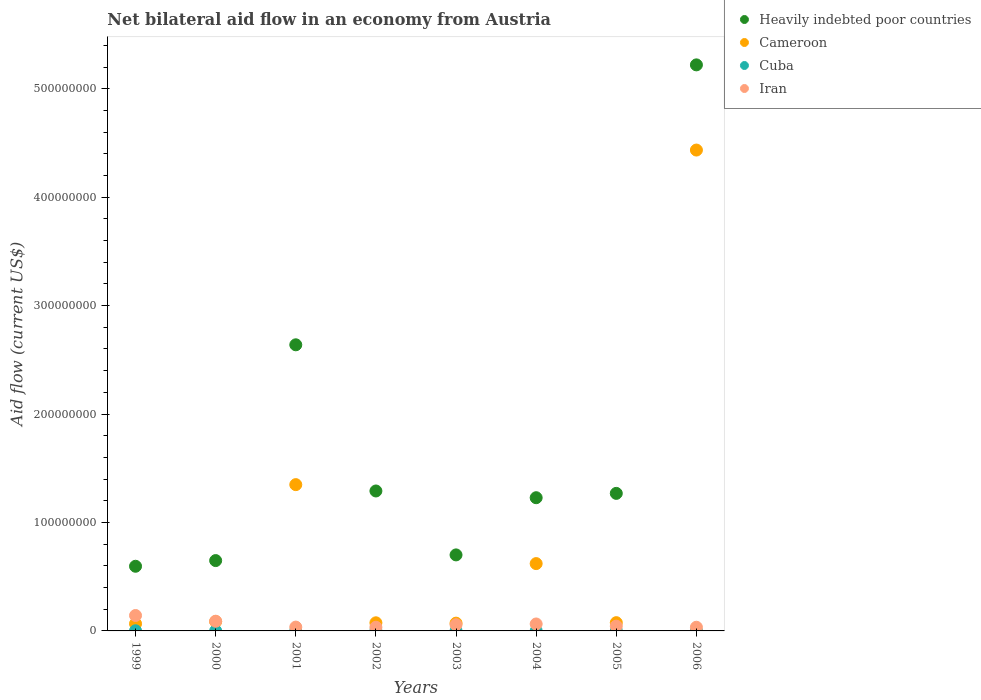Is the number of dotlines equal to the number of legend labels?
Your answer should be compact. Yes. What is the net bilateral aid flow in Cameroon in 2002?
Ensure brevity in your answer.  7.49e+06. Across all years, what is the minimum net bilateral aid flow in Heavily indebted poor countries?
Your answer should be compact. 5.96e+07. In which year was the net bilateral aid flow in Cuba maximum?
Provide a short and direct response. 2002. What is the total net bilateral aid flow in Cuba in the graph?
Make the answer very short. 9.40e+05. What is the difference between the net bilateral aid flow in Heavily indebted poor countries in 2005 and the net bilateral aid flow in Iran in 2001?
Give a very brief answer. 1.23e+08. What is the average net bilateral aid flow in Heavily indebted poor countries per year?
Ensure brevity in your answer.  1.70e+08. In the year 2005, what is the difference between the net bilateral aid flow in Cameroon and net bilateral aid flow in Iran?
Offer a terse response. 3.21e+06. What is the ratio of the net bilateral aid flow in Cameroon in 1999 to that in 2004?
Ensure brevity in your answer.  0.11. Is the net bilateral aid flow in Iran in 2001 less than that in 2006?
Give a very brief answer. No. Is the difference between the net bilateral aid flow in Cameroon in 1999 and 2006 greater than the difference between the net bilateral aid flow in Iran in 1999 and 2006?
Make the answer very short. No. What is the difference between the highest and the second highest net bilateral aid flow in Iran?
Your answer should be very brief. 5.27e+06. What is the difference between the highest and the lowest net bilateral aid flow in Heavily indebted poor countries?
Your response must be concise. 4.62e+08. Is the sum of the net bilateral aid flow in Cameroon in 1999 and 2006 greater than the maximum net bilateral aid flow in Iran across all years?
Keep it short and to the point. Yes. Does the net bilateral aid flow in Cuba monotonically increase over the years?
Ensure brevity in your answer.  No. Is the net bilateral aid flow in Heavily indebted poor countries strictly greater than the net bilateral aid flow in Cuba over the years?
Make the answer very short. Yes. Is the net bilateral aid flow in Iran strictly less than the net bilateral aid flow in Heavily indebted poor countries over the years?
Give a very brief answer. Yes. Are the values on the major ticks of Y-axis written in scientific E-notation?
Your answer should be very brief. No. Does the graph contain any zero values?
Offer a very short reply. No. Where does the legend appear in the graph?
Keep it short and to the point. Top right. What is the title of the graph?
Your response must be concise. Net bilateral aid flow in an economy from Austria. Does "Mongolia" appear as one of the legend labels in the graph?
Keep it short and to the point. No. What is the label or title of the Y-axis?
Your answer should be compact. Aid flow (current US$). What is the Aid flow (current US$) of Heavily indebted poor countries in 1999?
Ensure brevity in your answer.  5.96e+07. What is the Aid flow (current US$) in Cameroon in 1999?
Your answer should be very brief. 6.63e+06. What is the Aid flow (current US$) in Cuba in 1999?
Your answer should be very brief. 1.40e+05. What is the Aid flow (current US$) of Iran in 1999?
Your answer should be very brief. 1.42e+07. What is the Aid flow (current US$) in Heavily indebted poor countries in 2000?
Your answer should be compact. 6.49e+07. What is the Aid flow (current US$) of Cameroon in 2000?
Your response must be concise. 8.60e+06. What is the Aid flow (current US$) in Cuba in 2000?
Keep it short and to the point. 1.10e+05. What is the Aid flow (current US$) of Iran in 2000?
Your answer should be very brief. 8.95e+06. What is the Aid flow (current US$) in Heavily indebted poor countries in 2001?
Keep it short and to the point. 2.64e+08. What is the Aid flow (current US$) of Cameroon in 2001?
Provide a succinct answer. 1.35e+08. What is the Aid flow (current US$) in Cuba in 2001?
Offer a terse response. 9.00e+04. What is the Aid flow (current US$) of Iran in 2001?
Give a very brief answer. 3.53e+06. What is the Aid flow (current US$) in Heavily indebted poor countries in 2002?
Offer a very short reply. 1.29e+08. What is the Aid flow (current US$) in Cameroon in 2002?
Make the answer very short. 7.49e+06. What is the Aid flow (current US$) in Iran in 2002?
Make the answer very short. 3.38e+06. What is the Aid flow (current US$) of Heavily indebted poor countries in 2003?
Your answer should be compact. 7.01e+07. What is the Aid flow (current US$) in Cameroon in 2003?
Offer a very short reply. 7.17e+06. What is the Aid flow (current US$) of Iran in 2003?
Ensure brevity in your answer.  5.73e+06. What is the Aid flow (current US$) of Heavily indebted poor countries in 2004?
Offer a very short reply. 1.23e+08. What is the Aid flow (current US$) of Cameroon in 2004?
Keep it short and to the point. 6.21e+07. What is the Aid flow (current US$) of Cuba in 2004?
Offer a terse response. 1.00e+05. What is the Aid flow (current US$) in Iran in 2004?
Offer a very short reply. 6.40e+06. What is the Aid flow (current US$) in Heavily indebted poor countries in 2005?
Give a very brief answer. 1.27e+08. What is the Aid flow (current US$) in Cameroon in 2005?
Your answer should be compact. 7.61e+06. What is the Aid flow (current US$) in Iran in 2005?
Give a very brief answer. 4.40e+06. What is the Aid flow (current US$) in Heavily indebted poor countries in 2006?
Keep it short and to the point. 5.22e+08. What is the Aid flow (current US$) of Cameroon in 2006?
Offer a very short reply. 4.43e+08. What is the Aid flow (current US$) in Iran in 2006?
Offer a very short reply. 3.40e+06. Across all years, what is the maximum Aid flow (current US$) of Heavily indebted poor countries?
Your response must be concise. 5.22e+08. Across all years, what is the maximum Aid flow (current US$) of Cameroon?
Provide a short and direct response. 4.43e+08. Across all years, what is the maximum Aid flow (current US$) of Iran?
Your answer should be compact. 1.42e+07. Across all years, what is the minimum Aid flow (current US$) of Heavily indebted poor countries?
Give a very brief answer. 5.96e+07. Across all years, what is the minimum Aid flow (current US$) of Cameroon?
Keep it short and to the point. 6.63e+06. Across all years, what is the minimum Aid flow (current US$) in Iran?
Make the answer very short. 3.38e+06. What is the total Aid flow (current US$) in Heavily indebted poor countries in the graph?
Your answer should be very brief. 1.36e+09. What is the total Aid flow (current US$) in Cameroon in the graph?
Your answer should be very brief. 6.78e+08. What is the total Aid flow (current US$) in Cuba in the graph?
Your response must be concise. 9.40e+05. What is the total Aid flow (current US$) of Iran in the graph?
Provide a succinct answer. 5.00e+07. What is the difference between the Aid flow (current US$) in Heavily indebted poor countries in 1999 and that in 2000?
Offer a very short reply. -5.24e+06. What is the difference between the Aid flow (current US$) in Cameroon in 1999 and that in 2000?
Your answer should be very brief. -1.97e+06. What is the difference between the Aid flow (current US$) of Cuba in 1999 and that in 2000?
Make the answer very short. 3.00e+04. What is the difference between the Aid flow (current US$) in Iran in 1999 and that in 2000?
Offer a very short reply. 5.27e+06. What is the difference between the Aid flow (current US$) of Heavily indebted poor countries in 1999 and that in 2001?
Give a very brief answer. -2.04e+08. What is the difference between the Aid flow (current US$) in Cameroon in 1999 and that in 2001?
Your answer should be very brief. -1.28e+08. What is the difference between the Aid flow (current US$) in Cuba in 1999 and that in 2001?
Keep it short and to the point. 5.00e+04. What is the difference between the Aid flow (current US$) of Iran in 1999 and that in 2001?
Your answer should be compact. 1.07e+07. What is the difference between the Aid flow (current US$) of Heavily indebted poor countries in 1999 and that in 2002?
Your answer should be compact. -6.94e+07. What is the difference between the Aid flow (current US$) in Cameroon in 1999 and that in 2002?
Offer a terse response. -8.60e+05. What is the difference between the Aid flow (current US$) of Cuba in 1999 and that in 2002?
Your response must be concise. -9.00e+04. What is the difference between the Aid flow (current US$) in Iran in 1999 and that in 2002?
Offer a very short reply. 1.08e+07. What is the difference between the Aid flow (current US$) in Heavily indebted poor countries in 1999 and that in 2003?
Give a very brief answer. -1.05e+07. What is the difference between the Aid flow (current US$) in Cameroon in 1999 and that in 2003?
Offer a very short reply. -5.40e+05. What is the difference between the Aid flow (current US$) of Iran in 1999 and that in 2003?
Offer a terse response. 8.49e+06. What is the difference between the Aid flow (current US$) in Heavily indebted poor countries in 1999 and that in 2004?
Give a very brief answer. -6.32e+07. What is the difference between the Aid flow (current US$) in Cameroon in 1999 and that in 2004?
Your response must be concise. -5.55e+07. What is the difference between the Aid flow (current US$) of Cuba in 1999 and that in 2004?
Give a very brief answer. 4.00e+04. What is the difference between the Aid flow (current US$) in Iran in 1999 and that in 2004?
Provide a succinct answer. 7.82e+06. What is the difference between the Aid flow (current US$) in Heavily indebted poor countries in 1999 and that in 2005?
Ensure brevity in your answer.  -6.72e+07. What is the difference between the Aid flow (current US$) in Cameroon in 1999 and that in 2005?
Ensure brevity in your answer.  -9.80e+05. What is the difference between the Aid flow (current US$) of Cuba in 1999 and that in 2005?
Your response must be concise. 5.00e+04. What is the difference between the Aid flow (current US$) of Iran in 1999 and that in 2005?
Make the answer very short. 9.82e+06. What is the difference between the Aid flow (current US$) in Heavily indebted poor countries in 1999 and that in 2006?
Give a very brief answer. -4.62e+08. What is the difference between the Aid flow (current US$) in Cameroon in 1999 and that in 2006?
Provide a short and direct response. -4.37e+08. What is the difference between the Aid flow (current US$) in Iran in 1999 and that in 2006?
Make the answer very short. 1.08e+07. What is the difference between the Aid flow (current US$) of Heavily indebted poor countries in 2000 and that in 2001?
Offer a very short reply. -1.99e+08. What is the difference between the Aid flow (current US$) in Cameroon in 2000 and that in 2001?
Provide a short and direct response. -1.26e+08. What is the difference between the Aid flow (current US$) of Iran in 2000 and that in 2001?
Offer a very short reply. 5.42e+06. What is the difference between the Aid flow (current US$) of Heavily indebted poor countries in 2000 and that in 2002?
Give a very brief answer. -6.42e+07. What is the difference between the Aid flow (current US$) in Cameroon in 2000 and that in 2002?
Offer a very short reply. 1.11e+06. What is the difference between the Aid flow (current US$) in Cuba in 2000 and that in 2002?
Your answer should be compact. -1.20e+05. What is the difference between the Aid flow (current US$) in Iran in 2000 and that in 2002?
Your answer should be very brief. 5.57e+06. What is the difference between the Aid flow (current US$) of Heavily indebted poor countries in 2000 and that in 2003?
Offer a terse response. -5.24e+06. What is the difference between the Aid flow (current US$) in Cameroon in 2000 and that in 2003?
Your answer should be very brief. 1.43e+06. What is the difference between the Aid flow (current US$) of Cuba in 2000 and that in 2003?
Offer a terse response. 10000. What is the difference between the Aid flow (current US$) of Iran in 2000 and that in 2003?
Provide a succinct answer. 3.22e+06. What is the difference between the Aid flow (current US$) in Heavily indebted poor countries in 2000 and that in 2004?
Your answer should be compact. -5.80e+07. What is the difference between the Aid flow (current US$) of Cameroon in 2000 and that in 2004?
Ensure brevity in your answer.  -5.35e+07. What is the difference between the Aid flow (current US$) in Iran in 2000 and that in 2004?
Your answer should be compact. 2.55e+06. What is the difference between the Aid flow (current US$) of Heavily indebted poor countries in 2000 and that in 2005?
Your answer should be very brief. -6.20e+07. What is the difference between the Aid flow (current US$) in Cameroon in 2000 and that in 2005?
Offer a very short reply. 9.90e+05. What is the difference between the Aid flow (current US$) in Iran in 2000 and that in 2005?
Your response must be concise. 4.55e+06. What is the difference between the Aid flow (current US$) of Heavily indebted poor countries in 2000 and that in 2006?
Offer a terse response. -4.57e+08. What is the difference between the Aid flow (current US$) in Cameroon in 2000 and that in 2006?
Provide a succinct answer. -4.35e+08. What is the difference between the Aid flow (current US$) of Cuba in 2000 and that in 2006?
Keep it short and to the point. 3.00e+04. What is the difference between the Aid flow (current US$) of Iran in 2000 and that in 2006?
Provide a short and direct response. 5.55e+06. What is the difference between the Aid flow (current US$) of Heavily indebted poor countries in 2001 and that in 2002?
Offer a terse response. 1.35e+08. What is the difference between the Aid flow (current US$) in Cameroon in 2001 and that in 2002?
Make the answer very short. 1.27e+08. What is the difference between the Aid flow (current US$) in Heavily indebted poor countries in 2001 and that in 2003?
Ensure brevity in your answer.  1.94e+08. What is the difference between the Aid flow (current US$) in Cameroon in 2001 and that in 2003?
Offer a terse response. 1.28e+08. What is the difference between the Aid flow (current US$) in Cuba in 2001 and that in 2003?
Give a very brief answer. -10000. What is the difference between the Aid flow (current US$) of Iran in 2001 and that in 2003?
Offer a terse response. -2.20e+06. What is the difference between the Aid flow (current US$) in Heavily indebted poor countries in 2001 and that in 2004?
Provide a succinct answer. 1.41e+08. What is the difference between the Aid flow (current US$) in Cameroon in 2001 and that in 2004?
Offer a terse response. 7.28e+07. What is the difference between the Aid flow (current US$) of Iran in 2001 and that in 2004?
Offer a terse response. -2.87e+06. What is the difference between the Aid flow (current US$) of Heavily indebted poor countries in 2001 and that in 2005?
Make the answer very short. 1.37e+08. What is the difference between the Aid flow (current US$) in Cameroon in 2001 and that in 2005?
Offer a very short reply. 1.27e+08. What is the difference between the Aid flow (current US$) of Iran in 2001 and that in 2005?
Ensure brevity in your answer.  -8.70e+05. What is the difference between the Aid flow (current US$) of Heavily indebted poor countries in 2001 and that in 2006?
Keep it short and to the point. -2.58e+08. What is the difference between the Aid flow (current US$) of Cameroon in 2001 and that in 2006?
Make the answer very short. -3.09e+08. What is the difference between the Aid flow (current US$) in Iran in 2001 and that in 2006?
Keep it short and to the point. 1.30e+05. What is the difference between the Aid flow (current US$) in Heavily indebted poor countries in 2002 and that in 2003?
Offer a very short reply. 5.90e+07. What is the difference between the Aid flow (current US$) in Cuba in 2002 and that in 2003?
Your response must be concise. 1.30e+05. What is the difference between the Aid flow (current US$) of Iran in 2002 and that in 2003?
Your answer should be compact. -2.35e+06. What is the difference between the Aid flow (current US$) in Heavily indebted poor countries in 2002 and that in 2004?
Your answer should be very brief. 6.21e+06. What is the difference between the Aid flow (current US$) in Cameroon in 2002 and that in 2004?
Your answer should be very brief. -5.46e+07. What is the difference between the Aid flow (current US$) of Cuba in 2002 and that in 2004?
Make the answer very short. 1.30e+05. What is the difference between the Aid flow (current US$) of Iran in 2002 and that in 2004?
Your response must be concise. -3.02e+06. What is the difference between the Aid flow (current US$) of Heavily indebted poor countries in 2002 and that in 2005?
Offer a very short reply. 2.21e+06. What is the difference between the Aid flow (current US$) of Iran in 2002 and that in 2005?
Your response must be concise. -1.02e+06. What is the difference between the Aid flow (current US$) of Heavily indebted poor countries in 2002 and that in 2006?
Keep it short and to the point. -3.93e+08. What is the difference between the Aid flow (current US$) in Cameroon in 2002 and that in 2006?
Provide a succinct answer. -4.36e+08. What is the difference between the Aid flow (current US$) in Heavily indebted poor countries in 2003 and that in 2004?
Make the answer very short. -5.27e+07. What is the difference between the Aid flow (current US$) in Cameroon in 2003 and that in 2004?
Give a very brief answer. -5.49e+07. What is the difference between the Aid flow (current US$) in Iran in 2003 and that in 2004?
Your answer should be very brief. -6.70e+05. What is the difference between the Aid flow (current US$) in Heavily indebted poor countries in 2003 and that in 2005?
Offer a terse response. -5.67e+07. What is the difference between the Aid flow (current US$) in Cameroon in 2003 and that in 2005?
Ensure brevity in your answer.  -4.40e+05. What is the difference between the Aid flow (current US$) in Cuba in 2003 and that in 2005?
Offer a very short reply. 10000. What is the difference between the Aid flow (current US$) in Iran in 2003 and that in 2005?
Provide a short and direct response. 1.33e+06. What is the difference between the Aid flow (current US$) in Heavily indebted poor countries in 2003 and that in 2006?
Your response must be concise. -4.52e+08. What is the difference between the Aid flow (current US$) in Cameroon in 2003 and that in 2006?
Your answer should be very brief. -4.36e+08. What is the difference between the Aid flow (current US$) in Iran in 2003 and that in 2006?
Provide a succinct answer. 2.33e+06. What is the difference between the Aid flow (current US$) in Cameroon in 2004 and that in 2005?
Make the answer very short. 5.45e+07. What is the difference between the Aid flow (current US$) of Cuba in 2004 and that in 2005?
Offer a terse response. 10000. What is the difference between the Aid flow (current US$) of Heavily indebted poor countries in 2004 and that in 2006?
Offer a terse response. -3.99e+08. What is the difference between the Aid flow (current US$) of Cameroon in 2004 and that in 2006?
Your answer should be compact. -3.81e+08. What is the difference between the Aid flow (current US$) of Iran in 2004 and that in 2006?
Offer a terse response. 3.00e+06. What is the difference between the Aid flow (current US$) of Heavily indebted poor countries in 2005 and that in 2006?
Make the answer very short. -3.95e+08. What is the difference between the Aid flow (current US$) of Cameroon in 2005 and that in 2006?
Offer a terse response. -4.36e+08. What is the difference between the Aid flow (current US$) of Iran in 2005 and that in 2006?
Ensure brevity in your answer.  1.00e+06. What is the difference between the Aid flow (current US$) of Heavily indebted poor countries in 1999 and the Aid flow (current US$) of Cameroon in 2000?
Provide a short and direct response. 5.10e+07. What is the difference between the Aid flow (current US$) of Heavily indebted poor countries in 1999 and the Aid flow (current US$) of Cuba in 2000?
Provide a short and direct response. 5.95e+07. What is the difference between the Aid flow (current US$) in Heavily indebted poor countries in 1999 and the Aid flow (current US$) in Iran in 2000?
Ensure brevity in your answer.  5.07e+07. What is the difference between the Aid flow (current US$) in Cameroon in 1999 and the Aid flow (current US$) in Cuba in 2000?
Provide a short and direct response. 6.52e+06. What is the difference between the Aid flow (current US$) of Cameroon in 1999 and the Aid flow (current US$) of Iran in 2000?
Give a very brief answer. -2.32e+06. What is the difference between the Aid flow (current US$) of Cuba in 1999 and the Aid flow (current US$) of Iran in 2000?
Make the answer very short. -8.81e+06. What is the difference between the Aid flow (current US$) in Heavily indebted poor countries in 1999 and the Aid flow (current US$) in Cameroon in 2001?
Ensure brevity in your answer.  -7.53e+07. What is the difference between the Aid flow (current US$) in Heavily indebted poor countries in 1999 and the Aid flow (current US$) in Cuba in 2001?
Your answer should be compact. 5.95e+07. What is the difference between the Aid flow (current US$) of Heavily indebted poor countries in 1999 and the Aid flow (current US$) of Iran in 2001?
Provide a succinct answer. 5.61e+07. What is the difference between the Aid flow (current US$) of Cameroon in 1999 and the Aid flow (current US$) of Cuba in 2001?
Your response must be concise. 6.54e+06. What is the difference between the Aid flow (current US$) of Cameroon in 1999 and the Aid flow (current US$) of Iran in 2001?
Ensure brevity in your answer.  3.10e+06. What is the difference between the Aid flow (current US$) of Cuba in 1999 and the Aid flow (current US$) of Iran in 2001?
Give a very brief answer. -3.39e+06. What is the difference between the Aid flow (current US$) in Heavily indebted poor countries in 1999 and the Aid flow (current US$) in Cameroon in 2002?
Offer a very short reply. 5.21e+07. What is the difference between the Aid flow (current US$) of Heavily indebted poor countries in 1999 and the Aid flow (current US$) of Cuba in 2002?
Give a very brief answer. 5.94e+07. What is the difference between the Aid flow (current US$) of Heavily indebted poor countries in 1999 and the Aid flow (current US$) of Iran in 2002?
Provide a succinct answer. 5.62e+07. What is the difference between the Aid flow (current US$) of Cameroon in 1999 and the Aid flow (current US$) of Cuba in 2002?
Make the answer very short. 6.40e+06. What is the difference between the Aid flow (current US$) in Cameroon in 1999 and the Aid flow (current US$) in Iran in 2002?
Provide a short and direct response. 3.25e+06. What is the difference between the Aid flow (current US$) of Cuba in 1999 and the Aid flow (current US$) of Iran in 2002?
Give a very brief answer. -3.24e+06. What is the difference between the Aid flow (current US$) of Heavily indebted poor countries in 1999 and the Aid flow (current US$) of Cameroon in 2003?
Provide a short and direct response. 5.25e+07. What is the difference between the Aid flow (current US$) of Heavily indebted poor countries in 1999 and the Aid flow (current US$) of Cuba in 2003?
Your answer should be very brief. 5.95e+07. What is the difference between the Aid flow (current US$) of Heavily indebted poor countries in 1999 and the Aid flow (current US$) of Iran in 2003?
Your response must be concise. 5.39e+07. What is the difference between the Aid flow (current US$) of Cameroon in 1999 and the Aid flow (current US$) of Cuba in 2003?
Provide a succinct answer. 6.53e+06. What is the difference between the Aid flow (current US$) in Cameroon in 1999 and the Aid flow (current US$) in Iran in 2003?
Offer a terse response. 9.00e+05. What is the difference between the Aid flow (current US$) of Cuba in 1999 and the Aid flow (current US$) of Iran in 2003?
Your response must be concise. -5.59e+06. What is the difference between the Aid flow (current US$) in Heavily indebted poor countries in 1999 and the Aid flow (current US$) in Cameroon in 2004?
Provide a succinct answer. -2.46e+06. What is the difference between the Aid flow (current US$) of Heavily indebted poor countries in 1999 and the Aid flow (current US$) of Cuba in 2004?
Make the answer very short. 5.95e+07. What is the difference between the Aid flow (current US$) of Heavily indebted poor countries in 1999 and the Aid flow (current US$) of Iran in 2004?
Offer a very short reply. 5.32e+07. What is the difference between the Aid flow (current US$) in Cameroon in 1999 and the Aid flow (current US$) in Cuba in 2004?
Offer a very short reply. 6.53e+06. What is the difference between the Aid flow (current US$) of Cameroon in 1999 and the Aid flow (current US$) of Iran in 2004?
Provide a short and direct response. 2.30e+05. What is the difference between the Aid flow (current US$) of Cuba in 1999 and the Aid flow (current US$) of Iran in 2004?
Your answer should be very brief. -6.26e+06. What is the difference between the Aid flow (current US$) of Heavily indebted poor countries in 1999 and the Aid flow (current US$) of Cameroon in 2005?
Your answer should be very brief. 5.20e+07. What is the difference between the Aid flow (current US$) in Heavily indebted poor countries in 1999 and the Aid flow (current US$) in Cuba in 2005?
Keep it short and to the point. 5.95e+07. What is the difference between the Aid flow (current US$) in Heavily indebted poor countries in 1999 and the Aid flow (current US$) in Iran in 2005?
Provide a short and direct response. 5.52e+07. What is the difference between the Aid flow (current US$) of Cameroon in 1999 and the Aid flow (current US$) of Cuba in 2005?
Make the answer very short. 6.54e+06. What is the difference between the Aid flow (current US$) in Cameroon in 1999 and the Aid flow (current US$) in Iran in 2005?
Ensure brevity in your answer.  2.23e+06. What is the difference between the Aid flow (current US$) of Cuba in 1999 and the Aid flow (current US$) of Iran in 2005?
Offer a very short reply. -4.26e+06. What is the difference between the Aid flow (current US$) of Heavily indebted poor countries in 1999 and the Aid flow (current US$) of Cameroon in 2006?
Your answer should be very brief. -3.84e+08. What is the difference between the Aid flow (current US$) in Heavily indebted poor countries in 1999 and the Aid flow (current US$) in Cuba in 2006?
Provide a succinct answer. 5.96e+07. What is the difference between the Aid flow (current US$) of Heavily indebted poor countries in 1999 and the Aid flow (current US$) of Iran in 2006?
Make the answer very short. 5.62e+07. What is the difference between the Aid flow (current US$) in Cameroon in 1999 and the Aid flow (current US$) in Cuba in 2006?
Keep it short and to the point. 6.55e+06. What is the difference between the Aid flow (current US$) of Cameroon in 1999 and the Aid flow (current US$) of Iran in 2006?
Offer a terse response. 3.23e+06. What is the difference between the Aid flow (current US$) of Cuba in 1999 and the Aid flow (current US$) of Iran in 2006?
Provide a succinct answer. -3.26e+06. What is the difference between the Aid flow (current US$) of Heavily indebted poor countries in 2000 and the Aid flow (current US$) of Cameroon in 2001?
Offer a very short reply. -7.00e+07. What is the difference between the Aid flow (current US$) of Heavily indebted poor countries in 2000 and the Aid flow (current US$) of Cuba in 2001?
Give a very brief answer. 6.48e+07. What is the difference between the Aid flow (current US$) in Heavily indebted poor countries in 2000 and the Aid flow (current US$) in Iran in 2001?
Make the answer very short. 6.13e+07. What is the difference between the Aid flow (current US$) of Cameroon in 2000 and the Aid flow (current US$) of Cuba in 2001?
Keep it short and to the point. 8.51e+06. What is the difference between the Aid flow (current US$) of Cameroon in 2000 and the Aid flow (current US$) of Iran in 2001?
Make the answer very short. 5.07e+06. What is the difference between the Aid flow (current US$) of Cuba in 2000 and the Aid flow (current US$) of Iran in 2001?
Your answer should be very brief. -3.42e+06. What is the difference between the Aid flow (current US$) in Heavily indebted poor countries in 2000 and the Aid flow (current US$) in Cameroon in 2002?
Keep it short and to the point. 5.74e+07. What is the difference between the Aid flow (current US$) of Heavily indebted poor countries in 2000 and the Aid flow (current US$) of Cuba in 2002?
Keep it short and to the point. 6.46e+07. What is the difference between the Aid flow (current US$) of Heavily indebted poor countries in 2000 and the Aid flow (current US$) of Iran in 2002?
Your answer should be compact. 6.15e+07. What is the difference between the Aid flow (current US$) in Cameroon in 2000 and the Aid flow (current US$) in Cuba in 2002?
Your response must be concise. 8.37e+06. What is the difference between the Aid flow (current US$) of Cameroon in 2000 and the Aid flow (current US$) of Iran in 2002?
Ensure brevity in your answer.  5.22e+06. What is the difference between the Aid flow (current US$) of Cuba in 2000 and the Aid flow (current US$) of Iran in 2002?
Your response must be concise. -3.27e+06. What is the difference between the Aid flow (current US$) of Heavily indebted poor countries in 2000 and the Aid flow (current US$) of Cameroon in 2003?
Your answer should be very brief. 5.77e+07. What is the difference between the Aid flow (current US$) of Heavily indebted poor countries in 2000 and the Aid flow (current US$) of Cuba in 2003?
Your response must be concise. 6.48e+07. What is the difference between the Aid flow (current US$) of Heavily indebted poor countries in 2000 and the Aid flow (current US$) of Iran in 2003?
Offer a very short reply. 5.91e+07. What is the difference between the Aid flow (current US$) in Cameroon in 2000 and the Aid flow (current US$) in Cuba in 2003?
Provide a short and direct response. 8.50e+06. What is the difference between the Aid flow (current US$) in Cameroon in 2000 and the Aid flow (current US$) in Iran in 2003?
Your answer should be very brief. 2.87e+06. What is the difference between the Aid flow (current US$) of Cuba in 2000 and the Aid flow (current US$) of Iran in 2003?
Provide a short and direct response. -5.62e+06. What is the difference between the Aid flow (current US$) in Heavily indebted poor countries in 2000 and the Aid flow (current US$) in Cameroon in 2004?
Offer a very short reply. 2.78e+06. What is the difference between the Aid flow (current US$) of Heavily indebted poor countries in 2000 and the Aid flow (current US$) of Cuba in 2004?
Provide a short and direct response. 6.48e+07. What is the difference between the Aid flow (current US$) of Heavily indebted poor countries in 2000 and the Aid flow (current US$) of Iran in 2004?
Make the answer very short. 5.85e+07. What is the difference between the Aid flow (current US$) in Cameroon in 2000 and the Aid flow (current US$) in Cuba in 2004?
Your answer should be very brief. 8.50e+06. What is the difference between the Aid flow (current US$) in Cameroon in 2000 and the Aid flow (current US$) in Iran in 2004?
Ensure brevity in your answer.  2.20e+06. What is the difference between the Aid flow (current US$) in Cuba in 2000 and the Aid flow (current US$) in Iran in 2004?
Make the answer very short. -6.29e+06. What is the difference between the Aid flow (current US$) in Heavily indebted poor countries in 2000 and the Aid flow (current US$) in Cameroon in 2005?
Offer a terse response. 5.73e+07. What is the difference between the Aid flow (current US$) of Heavily indebted poor countries in 2000 and the Aid flow (current US$) of Cuba in 2005?
Offer a terse response. 6.48e+07. What is the difference between the Aid flow (current US$) in Heavily indebted poor countries in 2000 and the Aid flow (current US$) in Iran in 2005?
Your response must be concise. 6.05e+07. What is the difference between the Aid flow (current US$) of Cameroon in 2000 and the Aid flow (current US$) of Cuba in 2005?
Ensure brevity in your answer.  8.51e+06. What is the difference between the Aid flow (current US$) of Cameroon in 2000 and the Aid flow (current US$) of Iran in 2005?
Keep it short and to the point. 4.20e+06. What is the difference between the Aid flow (current US$) in Cuba in 2000 and the Aid flow (current US$) in Iran in 2005?
Ensure brevity in your answer.  -4.29e+06. What is the difference between the Aid flow (current US$) of Heavily indebted poor countries in 2000 and the Aid flow (current US$) of Cameroon in 2006?
Give a very brief answer. -3.79e+08. What is the difference between the Aid flow (current US$) in Heavily indebted poor countries in 2000 and the Aid flow (current US$) in Cuba in 2006?
Provide a succinct answer. 6.48e+07. What is the difference between the Aid flow (current US$) in Heavily indebted poor countries in 2000 and the Aid flow (current US$) in Iran in 2006?
Your answer should be compact. 6.15e+07. What is the difference between the Aid flow (current US$) of Cameroon in 2000 and the Aid flow (current US$) of Cuba in 2006?
Give a very brief answer. 8.52e+06. What is the difference between the Aid flow (current US$) in Cameroon in 2000 and the Aid flow (current US$) in Iran in 2006?
Provide a succinct answer. 5.20e+06. What is the difference between the Aid flow (current US$) in Cuba in 2000 and the Aid flow (current US$) in Iran in 2006?
Give a very brief answer. -3.29e+06. What is the difference between the Aid flow (current US$) in Heavily indebted poor countries in 2001 and the Aid flow (current US$) in Cameroon in 2002?
Your answer should be very brief. 2.56e+08. What is the difference between the Aid flow (current US$) of Heavily indebted poor countries in 2001 and the Aid flow (current US$) of Cuba in 2002?
Provide a succinct answer. 2.64e+08. What is the difference between the Aid flow (current US$) of Heavily indebted poor countries in 2001 and the Aid flow (current US$) of Iran in 2002?
Your answer should be compact. 2.60e+08. What is the difference between the Aid flow (current US$) of Cameroon in 2001 and the Aid flow (current US$) of Cuba in 2002?
Ensure brevity in your answer.  1.35e+08. What is the difference between the Aid flow (current US$) in Cameroon in 2001 and the Aid flow (current US$) in Iran in 2002?
Ensure brevity in your answer.  1.32e+08. What is the difference between the Aid flow (current US$) of Cuba in 2001 and the Aid flow (current US$) of Iran in 2002?
Offer a terse response. -3.29e+06. What is the difference between the Aid flow (current US$) of Heavily indebted poor countries in 2001 and the Aid flow (current US$) of Cameroon in 2003?
Your answer should be very brief. 2.57e+08. What is the difference between the Aid flow (current US$) of Heavily indebted poor countries in 2001 and the Aid flow (current US$) of Cuba in 2003?
Provide a short and direct response. 2.64e+08. What is the difference between the Aid flow (current US$) of Heavily indebted poor countries in 2001 and the Aid flow (current US$) of Iran in 2003?
Your response must be concise. 2.58e+08. What is the difference between the Aid flow (current US$) of Cameroon in 2001 and the Aid flow (current US$) of Cuba in 2003?
Keep it short and to the point. 1.35e+08. What is the difference between the Aid flow (current US$) in Cameroon in 2001 and the Aid flow (current US$) in Iran in 2003?
Provide a short and direct response. 1.29e+08. What is the difference between the Aid flow (current US$) in Cuba in 2001 and the Aid flow (current US$) in Iran in 2003?
Make the answer very short. -5.64e+06. What is the difference between the Aid flow (current US$) in Heavily indebted poor countries in 2001 and the Aid flow (current US$) in Cameroon in 2004?
Provide a succinct answer. 2.02e+08. What is the difference between the Aid flow (current US$) of Heavily indebted poor countries in 2001 and the Aid flow (current US$) of Cuba in 2004?
Provide a short and direct response. 2.64e+08. What is the difference between the Aid flow (current US$) in Heavily indebted poor countries in 2001 and the Aid flow (current US$) in Iran in 2004?
Offer a very short reply. 2.57e+08. What is the difference between the Aid flow (current US$) of Cameroon in 2001 and the Aid flow (current US$) of Cuba in 2004?
Keep it short and to the point. 1.35e+08. What is the difference between the Aid flow (current US$) of Cameroon in 2001 and the Aid flow (current US$) of Iran in 2004?
Give a very brief answer. 1.29e+08. What is the difference between the Aid flow (current US$) of Cuba in 2001 and the Aid flow (current US$) of Iran in 2004?
Your response must be concise. -6.31e+06. What is the difference between the Aid flow (current US$) of Heavily indebted poor countries in 2001 and the Aid flow (current US$) of Cameroon in 2005?
Ensure brevity in your answer.  2.56e+08. What is the difference between the Aid flow (current US$) of Heavily indebted poor countries in 2001 and the Aid flow (current US$) of Cuba in 2005?
Offer a very short reply. 2.64e+08. What is the difference between the Aid flow (current US$) in Heavily indebted poor countries in 2001 and the Aid flow (current US$) in Iran in 2005?
Offer a terse response. 2.59e+08. What is the difference between the Aid flow (current US$) in Cameroon in 2001 and the Aid flow (current US$) in Cuba in 2005?
Keep it short and to the point. 1.35e+08. What is the difference between the Aid flow (current US$) in Cameroon in 2001 and the Aid flow (current US$) in Iran in 2005?
Your answer should be compact. 1.31e+08. What is the difference between the Aid flow (current US$) in Cuba in 2001 and the Aid flow (current US$) in Iran in 2005?
Keep it short and to the point. -4.31e+06. What is the difference between the Aid flow (current US$) of Heavily indebted poor countries in 2001 and the Aid flow (current US$) of Cameroon in 2006?
Your answer should be very brief. -1.80e+08. What is the difference between the Aid flow (current US$) of Heavily indebted poor countries in 2001 and the Aid flow (current US$) of Cuba in 2006?
Make the answer very short. 2.64e+08. What is the difference between the Aid flow (current US$) of Heavily indebted poor countries in 2001 and the Aid flow (current US$) of Iran in 2006?
Your answer should be very brief. 2.60e+08. What is the difference between the Aid flow (current US$) of Cameroon in 2001 and the Aid flow (current US$) of Cuba in 2006?
Your response must be concise. 1.35e+08. What is the difference between the Aid flow (current US$) of Cameroon in 2001 and the Aid flow (current US$) of Iran in 2006?
Your response must be concise. 1.32e+08. What is the difference between the Aid flow (current US$) in Cuba in 2001 and the Aid flow (current US$) in Iran in 2006?
Provide a short and direct response. -3.31e+06. What is the difference between the Aid flow (current US$) in Heavily indebted poor countries in 2002 and the Aid flow (current US$) in Cameroon in 2003?
Provide a succinct answer. 1.22e+08. What is the difference between the Aid flow (current US$) in Heavily indebted poor countries in 2002 and the Aid flow (current US$) in Cuba in 2003?
Ensure brevity in your answer.  1.29e+08. What is the difference between the Aid flow (current US$) of Heavily indebted poor countries in 2002 and the Aid flow (current US$) of Iran in 2003?
Ensure brevity in your answer.  1.23e+08. What is the difference between the Aid flow (current US$) of Cameroon in 2002 and the Aid flow (current US$) of Cuba in 2003?
Keep it short and to the point. 7.39e+06. What is the difference between the Aid flow (current US$) of Cameroon in 2002 and the Aid flow (current US$) of Iran in 2003?
Offer a terse response. 1.76e+06. What is the difference between the Aid flow (current US$) of Cuba in 2002 and the Aid flow (current US$) of Iran in 2003?
Ensure brevity in your answer.  -5.50e+06. What is the difference between the Aid flow (current US$) of Heavily indebted poor countries in 2002 and the Aid flow (current US$) of Cameroon in 2004?
Offer a very short reply. 6.70e+07. What is the difference between the Aid flow (current US$) in Heavily indebted poor countries in 2002 and the Aid flow (current US$) in Cuba in 2004?
Provide a short and direct response. 1.29e+08. What is the difference between the Aid flow (current US$) of Heavily indebted poor countries in 2002 and the Aid flow (current US$) of Iran in 2004?
Keep it short and to the point. 1.23e+08. What is the difference between the Aid flow (current US$) in Cameroon in 2002 and the Aid flow (current US$) in Cuba in 2004?
Your response must be concise. 7.39e+06. What is the difference between the Aid flow (current US$) in Cameroon in 2002 and the Aid flow (current US$) in Iran in 2004?
Offer a terse response. 1.09e+06. What is the difference between the Aid flow (current US$) in Cuba in 2002 and the Aid flow (current US$) in Iran in 2004?
Make the answer very short. -6.17e+06. What is the difference between the Aid flow (current US$) of Heavily indebted poor countries in 2002 and the Aid flow (current US$) of Cameroon in 2005?
Make the answer very short. 1.21e+08. What is the difference between the Aid flow (current US$) of Heavily indebted poor countries in 2002 and the Aid flow (current US$) of Cuba in 2005?
Provide a succinct answer. 1.29e+08. What is the difference between the Aid flow (current US$) of Heavily indebted poor countries in 2002 and the Aid flow (current US$) of Iran in 2005?
Ensure brevity in your answer.  1.25e+08. What is the difference between the Aid flow (current US$) in Cameroon in 2002 and the Aid flow (current US$) in Cuba in 2005?
Make the answer very short. 7.40e+06. What is the difference between the Aid flow (current US$) in Cameroon in 2002 and the Aid flow (current US$) in Iran in 2005?
Offer a very short reply. 3.09e+06. What is the difference between the Aid flow (current US$) of Cuba in 2002 and the Aid flow (current US$) of Iran in 2005?
Your answer should be very brief. -4.17e+06. What is the difference between the Aid flow (current US$) of Heavily indebted poor countries in 2002 and the Aid flow (current US$) of Cameroon in 2006?
Your answer should be compact. -3.14e+08. What is the difference between the Aid flow (current US$) of Heavily indebted poor countries in 2002 and the Aid flow (current US$) of Cuba in 2006?
Keep it short and to the point. 1.29e+08. What is the difference between the Aid flow (current US$) in Heavily indebted poor countries in 2002 and the Aid flow (current US$) in Iran in 2006?
Give a very brief answer. 1.26e+08. What is the difference between the Aid flow (current US$) in Cameroon in 2002 and the Aid flow (current US$) in Cuba in 2006?
Your response must be concise. 7.41e+06. What is the difference between the Aid flow (current US$) of Cameroon in 2002 and the Aid flow (current US$) of Iran in 2006?
Your answer should be very brief. 4.09e+06. What is the difference between the Aid flow (current US$) of Cuba in 2002 and the Aid flow (current US$) of Iran in 2006?
Keep it short and to the point. -3.17e+06. What is the difference between the Aid flow (current US$) of Heavily indebted poor countries in 2003 and the Aid flow (current US$) of Cameroon in 2004?
Offer a very short reply. 8.02e+06. What is the difference between the Aid flow (current US$) in Heavily indebted poor countries in 2003 and the Aid flow (current US$) in Cuba in 2004?
Your response must be concise. 7.00e+07. What is the difference between the Aid flow (current US$) of Heavily indebted poor countries in 2003 and the Aid flow (current US$) of Iran in 2004?
Your answer should be compact. 6.37e+07. What is the difference between the Aid flow (current US$) in Cameroon in 2003 and the Aid flow (current US$) in Cuba in 2004?
Your answer should be very brief. 7.07e+06. What is the difference between the Aid flow (current US$) in Cameroon in 2003 and the Aid flow (current US$) in Iran in 2004?
Give a very brief answer. 7.70e+05. What is the difference between the Aid flow (current US$) of Cuba in 2003 and the Aid flow (current US$) of Iran in 2004?
Give a very brief answer. -6.30e+06. What is the difference between the Aid flow (current US$) in Heavily indebted poor countries in 2003 and the Aid flow (current US$) in Cameroon in 2005?
Offer a very short reply. 6.25e+07. What is the difference between the Aid flow (current US$) of Heavily indebted poor countries in 2003 and the Aid flow (current US$) of Cuba in 2005?
Ensure brevity in your answer.  7.00e+07. What is the difference between the Aid flow (current US$) of Heavily indebted poor countries in 2003 and the Aid flow (current US$) of Iran in 2005?
Keep it short and to the point. 6.57e+07. What is the difference between the Aid flow (current US$) of Cameroon in 2003 and the Aid flow (current US$) of Cuba in 2005?
Offer a very short reply. 7.08e+06. What is the difference between the Aid flow (current US$) in Cameroon in 2003 and the Aid flow (current US$) in Iran in 2005?
Your answer should be very brief. 2.77e+06. What is the difference between the Aid flow (current US$) of Cuba in 2003 and the Aid flow (current US$) of Iran in 2005?
Offer a terse response. -4.30e+06. What is the difference between the Aid flow (current US$) in Heavily indebted poor countries in 2003 and the Aid flow (current US$) in Cameroon in 2006?
Provide a succinct answer. -3.73e+08. What is the difference between the Aid flow (current US$) in Heavily indebted poor countries in 2003 and the Aid flow (current US$) in Cuba in 2006?
Provide a short and direct response. 7.00e+07. What is the difference between the Aid flow (current US$) of Heavily indebted poor countries in 2003 and the Aid flow (current US$) of Iran in 2006?
Give a very brief answer. 6.67e+07. What is the difference between the Aid flow (current US$) of Cameroon in 2003 and the Aid flow (current US$) of Cuba in 2006?
Your response must be concise. 7.09e+06. What is the difference between the Aid flow (current US$) in Cameroon in 2003 and the Aid flow (current US$) in Iran in 2006?
Your answer should be very brief. 3.77e+06. What is the difference between the Aid flow (current US$) in Cuba in 2003 and the Aid flow (current US$) in Iran in 2006?
Your response must be concise. -3.30e+06. What is the difference between the Aid flow (current US$) of Heavily indebted poor countries in 2004 and the Aid flow (current US$) of Cameroon in 2005?
Make the answer very short. 1.15e+08. What is the difference between the Aid flow (current US$) in Heavily indebted poor countries in 2004 and the Aid flow (current US$) in Cuba in 2005?
Your answer should be very brief. 1.23e+08. What is the difference between the Aid flow (current US$) of Heavily indebted poor countries in 2004 and the Aid flow (current US$) of Iran in 2005?
Your answer should be compact. 1.18e+08. What is the difference between the Aid flow (current US$) in Cameroon in 2004 and the Aid flow (current US$) in Cuba in 2005?
Provide a succinct answer. 6.20e+07. What is the difference between the Aid flow (current US$) in Cameroon in 2004 and the Aid flow (current US$) in Iran in 2005?
Make the answer very short. 5.77e+07. What is the difference between the Aid flow (current US$) in Cuba in 2004 and the Aid flow (current US$) in Iran in 2005?
Provide a short and direct response. -4.30e+06. What is the difference between the Aid flow (current US$) of Heavily indebted poor countries in 2004 and the Aid flow (current US$) of Cameroon in 2006?
Your answer should be very brief. -3.21e+08. What is the difference between the Aid flow (current US$) of Heavily indebted poor countries in 2004 and the Aid flow (current US$) of Cuba in 2006?
Ensure brevity in your answer.  1.23e+08. What is the difference between the Aid flow (current US$) in Heavily indebted poor countries in 2004 and the Aid flow (current US$) in Iran in 2006?
Provide a short and direct response. 1.19e+08. What is the difference between the Aid flow (current US$) of Cameroon in 2004 and the Aid flow (current US$) of Cuba in 2006?
Ensure brevity in your answer.  6.20e+07. What is the difference between the Aid flow (current US$) in Cameroon in 2004 and the Aid flow (current US$) in Iran in 2006?
Offer a very short reply. 5.87e+07. What is the difference between the Aid flow (current US$) of Cuba in 2004 and the Aid flow (current US$) of Iran in 2006?
Offer a very short reply. -3.30e+06. What is the difference between the Aid flow (current US$) of Heavily indebted poor countries in 2005 and the Aid flow (current US$) of Cameroon in 2006?
Make the answer very short. -3.17e+08. What is the difference between the Aid flow (current US$) of Heavily indebted poor countries in 2005 and the Aid flow (current US$) of Cuba in 2006?
Give a very brief answer. 1.27e+08. What is the difference between the Aid flow (current US$) of Heavily indebted poor countries in 2005 and the Aid flow (current US$) of Iran in 2006?
Keep it short and to the point. 1.23e+08. What is the difference between the Aid flow (current US$) in Cameroon in 2005 and the Aid flow (current US$) in Cuba in 2006?
Give a very brief answer. 7.53e+06. What is the difference between the Aid flow (current US$) of Cameroon in 2005 and the Aid flow (current US$) of Iran in 2006?
Keep it short and to the point. 4.21e+06. What is the difference between the Aid flow (current US$) of Cuba in 2005 and the Aid flow (current US$) of Iran in 2006?
Make the answer very short. -3.31e+06. What is the average Aid flow (current US$) of Heavily indebted poor countries per year?
Provide a short and direct response. 1.70e+08. What is the average Aid flow (current US$) of Cameroon per year?
Your response must be concise. 8.47e+07. What is the average Aid flow (current US$) of Cuba per year?
Offer a terse response. 1.18e+05. What is the average Aid flow (current US$) of Iran per year?
Your answer should be very brief. 6.25e+06. In the year 1999, what is the difference between the Aid flow (current US$) of Heavily indebted poor countries and Aid flow (current US$) of Cameroon?
Offer a very short reply. 5.30e+07. In the year 1999, what is the difference between the Aid flow (current US$) of Heavily indebted poor countries and Aid flow (current US$) of Cuba?
Keep it short and to the point. 5.95e+07. In the year 1999, what is the difference between the Aid flow (current US$) in Heavily indebted poor countries and Aid flow (current US$) in Iran?
Offer a terse response. 4.54e+07. In the year 1999, what is the difference between the Aid flow (current US$) in Cameroon and Aid flow (current US$) in Cuba?
Keep it short and to the point. 6.49e+06. In the year 1999, what is the difference between the Aid flow (current US$) in Cameroon and Aid flow (current US$) in Iran?
Provide a short and direct response. -7.59e+06. In the year 1999, what is the difference between the Aid flow (current US$) of Cuba and Aid flow (current US$) of Iran?
Provide a succinct answer. -1.41e+07. In the year 2000, what is the difference between the Aid flow (current US$) in Heavily indebted poor countries and Aid flow (current US$) in Cameroon?
Your answer should be compact. 5.63e+07. In the year 2000, what is the difference between the Aid flow (current US$) in Heavily indebted poor countries and Aid flow (current US$) in Cuba?
Your answer should be compact. 6.48e+07. In the year 2000, what is the difference between the Aid flow (current US$) in Heavily indebted poor countries and Aid flow (current US$) in Iran?
Your answer should be very brief. 5.59e+07. In the year 2000, what is the difference between the Aid flow (current US$) in Cameroon and Aid flow (current US$) in Cuba?
Keep it short and to the point. 8.49e+06. In the year 2000, what is the difference between the Aid flow (current US$) of Cameroon and Aid flow (current US$) of Iran?
Your answer should be very brief. -3.50e+05. In the year 2000, what is the difference between the Aid flow (current US$) of Cuba and Aid flow (current US$) of Iran?
Ensure brevity in your answer.  -8.84e+06. In the year 2001, what is the difference between the Aid flow (current US$) in Heavily indebted poor countries and Aid flow (current US$) in Cameroon?
Offer a terse response. 1.29e+08. In the year 2001, what is the difference between the Aid flow (current US$) in Heavily indebted poor countries and Aid flow (current US$) in Cuba?
Offer a terse response. 2.64e+08. In the year 2001, what is the difference between the Aid flow (current US$) in Heavily indebted poor countries and Aid flow (current US$) in Iran?
Offer a very short reply. 2.60e+08. In the year 2001, what is the difference between the Aid flow (current US$) in Cameroon and Aid flow (current US$) in Cuba?
Keep it short and to the point. 1.35e+08. In the year 2001, what is the difference between the Aid flow (current US$) of Cameroon and Aid flow (current US$) of Iran?
Keep it short and to the point. 1.31e+08. In the year 2001, what is the difference between the Aid flow (current US$) of Cuba and Aid flow (current US$) of Iran?
Give a very brief answer. -3.44e+06. In the year 2002, what is the difference between the Aid flow (current US$) in Heavily indebted poor countries and Aid flow (current US$) in Cameroon?
Provide a succinct answer. 1.22e+08. In the year 2002, what is the difference between the Aid flow (current US$) in Heavily indebted poor countries and Aid flow (current US$) in Cuba?
Your answer should be very brief. 1.29e+08. In the year 2002, what is the difference between the Aid flow (current US$) of Heavily indebted poor countries and Aid flow (current US$) of Iran?
Your answer should be compact. 1.26e+08. In the year 2002, what is the difference between the Aid flow (current US$) in Cameroon and Aid flow (current US$) in Cuba?
Keep it short and to the point. 7.26e+06. In the year 2002, what is the difference between the Aid flow (current US$) in Cameroon and Aid flow (current US$) in Iran?
Your answer should be very brief. 4.11e+06. In the year 2002, what is the difference between the Aid flow (current US$) of Cuba and Aid flow (current US$) of Iran?
Keep it short and to the point. -3.15e+06. In the year 2003, what is the difference between the Aid flow (current US$) of Heavily indebted poor countries and Aid flow (current US$) of Cameroon?
Give a very brief answer. 6.29e+07. In the year 2003, what is the difference between the Aid flow (current US$) in Heavily indebted poor countries and Aid flow (current US$) in Cuba?
Give a very brief answer. 7.00e+07. In the year 2003, what is the difference between the Aid flow (current US$) in Heavily indebted poor countries and Aid flow (current US$) in Iran?
Provide a succinct answer. 6.44e+07. In the year 2003, what is the difference between the Aid flow (current US$) in Cameroon and Aid flow (current US$) in Cuba?
Your answer should be compact. 7.07e+06. In the year 2003, what is the difference between the Aid flow (current US$) of Cameroon and Aid flow (current US$) of Iran?
Provide a succinct answer. 1.44e+06. In the year 2003, what is the difference between the Aid flow (current US$) of Cuba and Aid flow (current US$) of Iran?
Your answer should be compact. -5.63e+06. In the year 2004, what is the difference between the Aid flow (current US$) in Heavily indebted poor countries and Aid flow (current US$) in Cameroon?
Your answer should be compact. 6.08e+07. In the year 2004, what is the difference between the Aid flow (current US$) in Heavily indebted poor countries and Aid flow (current US$) in Cuba?
Provide a short and direct response. 1.23e+08. In the year 2004, what is the difference between the Aid flow (current US$) in Heavily indebted poor countries and Aid flow (current US$) in Iran?
Your response must be concise. 1.16e+08. In the year 2004, what is the difference between the Aid flow (current US$) in Cameroon and Aid flow (current US$) in Cuba?
Make the answer very short. 6.20e+07. In the year 2004, what is the difference between the Aid flow (current US$) of Cameroon and Aid flow (current US$) of Iran?
Give a very brief answer. 5.57e+07. In the year 2004, what is the difference between the Aid flow (current US$) in Cuba and Aid flow (current US$) in Iran?
Make the answer very short. -6.30e+06. In the year 2005, what is the difference between the Aid flow (current US$) of Heavily indebted poor countries and Aid flow (current US$) of Cameroon?
Provide a short and direct response. 1.19e+08. In the year 2005, what is the difference between the Aid flow (current US$) of Heavily indebted poor countries and Aid flow (current US$) of Cuba?
Offer a very short reply. 1.27e+08. In the year 2005, what is the difference between the Aid flow (current US$) in Heavily indebted poor countries and Aid flow (current US$) in Iran?
Provide a short and direct response. 1.22e+08. In the year 2005, what is the difference between the Aid flow (current US$) of Cameroon and Aid flow (current US$) of Cuba?
Your answer should be very brief. 7.52e+06. In the year 2005, what is the difference between the Aid flow (current US$) of Cameroon and Aid flow (current US$) of Iran?
Ensure brevity in your answer.  3.21e+06. In the year 2005, what is the difference between the Aid flow (current US$) in Cuba and Aid flow (current US$) in Iran?
Your answer should be very brief. -4.31e+06. In the year 2006, what is the difference between the Aid flow (current US$) in Heavily indebted poor countries and Aid flow (current US$) in Cameroon?
Provide a succinct answer. 7.86e+07. In the year 2006, what is the difference between the Aid flow (current US$) of Heavily indebted poor countries and Aid flow (current US$) of Cuba?
Your answer should be very brief. 5.22e+08. In the year 2006, what is the difference between the Aid flow (current US$) of Heavily indebted poor countries and Aid flow (current US$) of Iran?
Keep it short and to the point. 5.19e+08. In the year 2006, what is the difference between the Aid flow (current US$) in Cameroon and Aid flow (current US$) in Cuba?
Offer a very short reply. 4.43e+08. In the year 2006, what is the difference between the Aid flow (current US$) of Cameroon and Aid flow (current US$) of Iran?
Provide a succinct answer. 4.40e+08. In the year 2006, what is the difference between the Aid flow (current US$) in Cuba and Aid flow (current US$) in Iran?
Offer a terse response. -3.32e+06. What is the ratio of the Aid flow (current US$) in Heavily indebted poor countries in 1999 to that in 2000?
Keep it short and to the point. 0.92. What is the ratio of the Aid flow (current US$) in Cameroon in 1999 to that in 2000?
Ensure brevity in your answer.  0.77. What is the ratio of the Aid flow (current US$) of Cuba in 1999 to that in 2000?
Provide a succinct answer. 1.27. What is the ratio of the Aid flow (current US$) in Iran in 1999 to that in 2000?
Offer a terse response. 1.59. What is the ratio of the Aid flow (current US$) of Heavily indebted poor countries in 1999 to that in 2001?
Offer a terse response. 0.23. What is the ratio of the Aid flow (current US$) of Cameroon in 1999 to that in 2001?
Keep it short and to the point. 0.05. What is the ratio of the Aid flow (current US$) of Cuba in 1999 to that in 2001?
Give a very brief answer. 1.56. What is the ratio of the Aid flow (current US$) of Iran in 1999 to that in 2001?
Give a very brief answer. 4.03. What is the ratio of the Aid flow (current US$) of Heavily indebted poor countries in 1999 to that in 2002?
Offer a very short reply. 0.46. What is the ratio of the Aid flow (current US$) in Cameroon in 1999 to that in 2002?
Make the answer very short. 0.89. What is the ratio of the Aid flow (current US$) in Cuba in 1999 to that in 2002?
Provide a succinct answer. 0.61. What is the ratio of the Aid flow (current US$) of Iran in 1999 to that in 2002?
Offer a very short reply. 4.21. What is the ratio of the Aid flow (current US$) in Heavily indebted poor countries in 1999 to that in 2003?
Your answer should be compact. 0.85. What is the ratio of the Aid flow (current US$) of Cameroon in 1999 to that in 2003?
Offer a terse response. 0.92. What is the ratio of the Aid flow (current US$) of Cuba in 1999 to that in 2003?
Provide a succinct answer. 1.4. What is the ratio of the Aid flow (current US$) in Iran in 1999 to that in 2003?
Ensure brevity in your answer.  2.48. What is the ratio of the Aid flow (current US$) in Heavily indebted poor countries in 1999 to that in 2004?
Make the answer very short. 0.49. What is the ratio of the Aid flow (current US$) in Cameroon in 1999 to that in 2004?
Ensure brevity in your answer.  0.11. What is the ratio of the Aid flow (current US$) in Cuba in 1999 to that in 2004?
Give a very brief answer. 1.4. What is the ratio of the Aid flow (current US$) in Iran in 1999 to that in 2004?
Provide a succinct answer. 2.22. What is the ratio of the Aid flow (current US$) of Heavily indebted poor countries in 1999 to that in 2005?
Provide a short and direct response. 0.47. What is the ratio of the Aid flow (current US$) of Cameroon in 1999 to that in 2005?
Offer a terse response. 0.87. What is the ratio of the Aid flow (current US$) of Cuba in 1999 to that in 2005?
Offer a terse response. 1.56. What is the ratio of the Aid flow (current US$) of Iran in 1999 to that in 2005?
Keep it short and to the point. 3.23. What is the ratio of the Aid flow (current US$) of Heavily indebted poor countries in 1999 to that in 2006?
Ensure brevity in your answer.  0.11. What is the ratio of the Aid flow (current US$) of Cameroon in 1999 to that in 2006?
Your answer should be very brief. 0.01. What is the ratio of the Aid flow (current US$) of Iran in 1999 to that in 2006?
Make the answer very short. 4.18. What is the ratio of the Aid flow (current US$) of Heavily indebted poor countries in 2000 to that in 2001?
Provide a short and direct response. 0.25. What is the ratio of the Aid flow (current US$) of Cameroon in 2000 to that in 2001?
Offer a terse response. 0.06. What is the ratio of the Aid flow (current US$) of Cuba in 2000 to that in 2001?
Offer a very short reply. 1.22. What is the ratio of the Aid flow (current US$) of Iran in 2000 to that in 2001?
Offer a terse response. 2.54. What is the ratio of the Aid flow (current US$) in Heavily indebted poor countries in 2000 to that in 2002?
Offer a terse response. 0.5. What is the ratio of the Aid flow (current US$) of Cameroon in 2000 to that in 2002?
Your answer should be very brief. 1.15. What is the ratio of the Aid flow (current US$) of Cuba in 2000 to that in 2002?
Your answer should be very brief. 0.48. What is the ratio of the Aid flow (current US$) of Iran in 2000 to that in 2002?
Offer a terse response. 2.65. What is the ratio of the Aid flow (current US$) in Heavily indebted poor countries in 2000 to that in 2003?
Give a very brief answer. 0.93. What is the ratio of the Aid flow (current US$) in Cameroon in 2000 to that in 2003?
Give a very brief answer. 1.2. What is the ratio of the Aid flow (current US$) of Cuba in 2000 to that in 2003?
Offer a terse response. 1.1. What is the ratio of the Aid flow (current US$) in Iran in 2000 to that in 2003?
Offer a very short reply. 1.56. What is the ratio of the Aid flow (current US$) of Heavily indebted poor countries in 2000 to that in 2004?
Make the answer very short. 0.53. What is the ratio of the Aid flow (current US$) in Cameroon in 2000 to that in 2004?
Offer a very short reply. 0.14. What is the ratio of the Aid flow (current US$) in Iran in 2000 to that in 2004?
Offer a terse response. 1.4. What is the ratio of the Aid flow (current US$) in Heavily indebted poor countries in 2000 to that in 2005?
Offer a terse response. 0.51. What is the ratio of the Aid flow (current US$) in Cameroon in 2000 to that in 2005?
Your answer should be compact. 1.13. What is the ratio of the Aid flow (current US$) of Cuba in 2000 to that in 2005?
Your response must be concise. 1.22. What is the ratio of the Aid flow (current US$) of Iran in 2000 to that in 2005?
Your answer should be very brief. 2.03. What is the ratio of the Aid flow (current US$) of Heavily indebted poor countries in 2000 to that in 2006?
Provide a succinct answer. 0.12. What is the ratio of the Aid flow (current US$) in Cameroon in 2000 to that in 2006?
Ensure brevity in your answer.  0.02. What is the ratio of the Aid flow (current US$) in Cuba in 2000 to that in 2006?
Your response must be concise. 1.38. What is the ratio of the Aid flow (current US$) in Iran in 2000 to that in 2006?
Your answer should be very brief. 2.63. What is the ratio of the Aid flow (current US$) in Heavily indebted poor countries in 2001 to that in 2002?
Keep it short and to the point. 2.04. What is the ratio of the Aid flow (current US$) in Cameroon in 2001 to that in 2002?
Your answer should be compact. 18.01. What is the ratio of the Aid flow (current US$) of Cuba in 2001 to that in 2002?
Your answer should be compact. 0.39. What is the ratio of the Aid flow (current US$) of Iran in 2001 to that in 2002?
Make the answer very short. 1.04. What is the ratio of the Aid flow (current US$) of Heavily indebted poor countries in 2001 to that in 2003?
Your answer should be compact. 3.76. What is the ratio of the Aid flow (current US$) in Cameroon in 2001 to that in 2003?
Your response must be concise. 18.82. What is the ratio of the Aid flow (current US$) in Cuba in 2001 to that in 2003?
Offer a terse response. 0.9. What is the ratio of the Aid flow (current US$) of Iran in 2001 to that in 2003?
Offer a terse response. 0.62. What is the ratio of the Aid flow (current US$) in Heavily indebted poor countries in 2001 to that in 2004?
Give a very brief answer. 2.15. What is the ratio of the Aid flow (current US$) in Cameroon in 2001 to that in 2004?
Keep it short and to the point. 2.17. What is the ratio of the Aid flow (current US$) in Cuba in 2001 to that in 2004?
Give a very brief answer. 0.9. What is the ratio of the Aid flow (current US$) of Iran in 2001 to that in 2004?
Provide a short and direct response. 0.55. What is the ratio of the Aid flow (current US$) of Heavily indebted poor countries in 2001 to that in 2005?
Give a very brief answer. 2.08. What is the ratio of the Aid flow (current US$) in Cameroon in 2001 to that in 2005?
Your answer should be very brief. 17.73. What is the ratio of the Aid flow (current US$) of Iran in 2001 to that in 2005?
Ensure brevity in your answer.  0.8. What is the ratio of the Aid flow (current US$) in Heavily indebted poor countries in 2001 to that in 2006?
Keep it short and to the point. 0.51. What is the ratio of the Aid flow (current US$) in Cameroon in 2001 to that in 2006?
Provide a succinct answer. 0.3. What is the ratio of the Aid flow (current US$) of Iran in 2001 to that in 2006?
Offer a very short reply. 1.04. What is the ratio of the Aid flow (current US$) of Heavily indebted poor countries in 2002 to that in 2003?
Provide a succinct answer. 1.84. What is the ratio of the Aid flow (current US$) in Cameroon in 2002 to that in 2003?
Offer a terse response. 1.04. What is the ratio of the Aid flow (current US$) of Iran in 2002 to that in 2003?
Your answer should be very brief. 0.59. What is the ratio of the Aid flow (current US$) in Heavily indebted poor countries in 2002 to that in 2004?
Make the answer very short. 1.05. What is the ratio of the Aid flow (current US$) of Cameroon in 2002 to that in 2004?
Your answer should be very brief. 0.12. What is the ratio of the Aid flow (current US$) of Cuba in 2002 to that in 2004?
Provide a succinct answer. 2.3. What is the ratio of the Aid flow (current US$) in Iran in 2002 to that in 2004?
Your answer should be very brief. 0.53. What is the ratio of the Aid flow (current US$) of Heavily indebted poor countries in 2002 to that in 2005?
Your answer should be compact. 1.02. What is the ratio of the Aid flow (current US$) of Cameroon in 2002 to that in 2005?
Your answer should be compact. 0.98. What is the ratio of the Aid flow (current US$) of Cuba in 2002 to that in 2005?
Your answer should be compact. 2.56. What is the ratio of the Aid flow (current US$) of Iran in 2002 to that in 2005?
Make the answer very short. 0.77. What is the ratio of the Aid flow (current US$) in Heavily indebted poor countries in 2002 to that in 2006?
Your answer should be very brief. 0.25. What is the ratio of the Aid flow (current US$) in Cameroon in 2002 to that in 2006?
Keep it short and to the point. 0.02. What is the ratio of the Aid flow (current US$) of Cuba in 2002 to that in 2006?
Your response must be concise. 2.88. What is the ratio of the Aid flow (current US$) of Iran in 2002 to that in 2006?
Offer a terse response. 0.99. What is the ratio of the Aid flow (current US$) of Heavily indebted poor countries in 2003 to that in 2004?
Provide a succinct answer. 0.57. What is the ratio of the Aid flow (current US$) of Cameroon in 2003 to that in 2004?
Give a very brief answer. 0.12. What is the ratio of the Aid flow (current US$) of Cuba in 2003 to that in 2004?
Ensure brevity in your answer.  1. What is the ratio of the Aid flow (current US$) in Iran in 2003 to that in 2004?
Give a very brief answer. 0.9. What is the ratio of the Aid flow (current US$) of Heavily indebted poor countries in 2003 to that in 2005?
Make the answer very short. 0.55. What is the ratio of the Aid flow (current US$) of Cameroon in 2003 to that in 2005?
Your answer should be very brief. 0.94. What is the ratio of the Aid flow (current US$) in Cuba in 2003 to that in 2005?
Your answer should be very brief. 1.11. What is the ratio of the Aid flow (current US$) in Iran in 2003 to that in 2005?
Provide a succinct answer. 1.3. What is the ratio of the Aid flow (current US$) of Heavily indebted poor countries in 2003 to that in 2006?
Your response must be concise. 0.13. What is the ratio of the Aid flow (current US$) of Cameroon in 2003 to that in 2006?
Provide a succinct answer. 0.02. What is the ratio of the Aid flow (current US$) in Iran in 2003 to that in 2006?
Your answer should be very brief. 1.69. What is the ratio of the Aid flow (current US$) in Heavily indebted poor countries in 2004 to that in 2005?
Keep it short and to the point. 0.97. What is the ratio of the Aid flow (current US$) of Cameroon in 2004 to that in 2005?
Your answer should be compact. 8.16. What is the ratio of the Aid flow (current US$) of Cuba in 2004 to that in 2005?
Provide a short and direct response. 1.11. What is the ratio of the Aid flow (current US$) in Iran in 2004 to that in 2005?
Offer a terse response. 1.45. What is the ratio of the Aid flow (current US$) of Heavily indebted poor countries in 2004 to that in 2006?
Your answer should be compact. 0.24. What is the ratio of the Aid flow (current US$) in Cameroon in 2004 to that in 2006?
Offer a terse response. 0.14. What is the ratio of the Aid flow (current US$) in Cuba in 2004 to that in 2006?
Keep it short and to the point. 1.25. What is the ratio of the Aid flow (current US$) of Iran in 2004 to that in 2006?
Offer a terse response. 1.88. What is the ratio of the Aid flow (current US$) in Heavily indebted poor countries in 2005 to that in 2006?
Make the answer very short. 0.24. What is the ratio of the Aid flow (current US$) of Cameroon in 2005 to that in 2006?
Offer a terse response. 0.02. What is the ratio of the Aid flow (current US$) of Cuba in 2005 to that in 2006?
Keep it short and to the point. 1.12. What is the ratio of the Aid flow (current US$) of Iran in 2005 to that in 2006?
Make the answer very short. 1.29. What is the difference between the highest and the second highest Aid flow (current US$) in Heavily indebted poor countries?
Your answer should be compact. 2.58e+08. What is the difference between the highest and the second highest Aid flow (current US$) in Cameroon?
Offer a very short reply. 3.09e+08. What is the difference between the highest and the second highest Aid flow (current US$) in Iran?
Your response must be concise. 5.27e+06. What is the difference between the highest and the lowest Aid flow (current US$) in Heavily indebted poor countries?
Your answer should be compact. 4.62e+08. What is the difference between the highest and the lowest Aid flow (current US$) in Cameroon?
Provide a short and direct response. 4.37e+08. What is the difference between the highest and the lowest Aid flow (current US$) in Iran?
Your answer should be compact. 1.08e+07. 